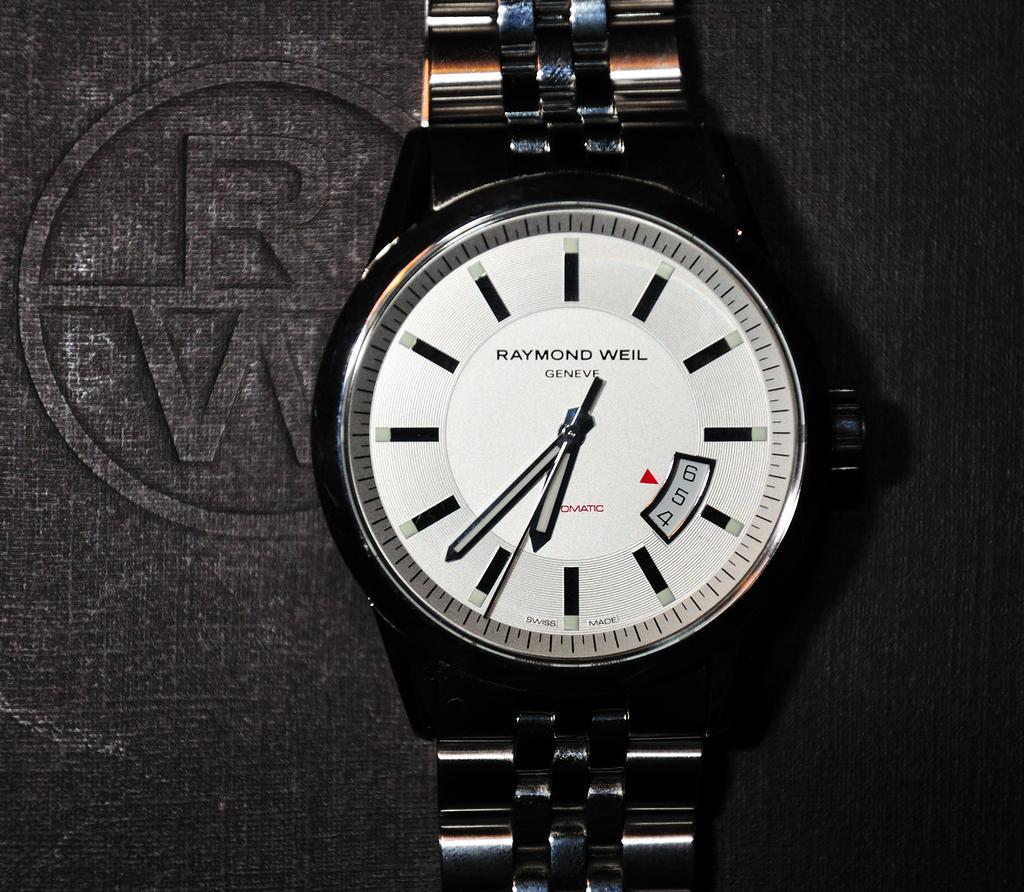What is the brand of watch?
Your response must be concise. Raymond weil. What time is it on the watch?
Keep it short and to the point. 6:37. 